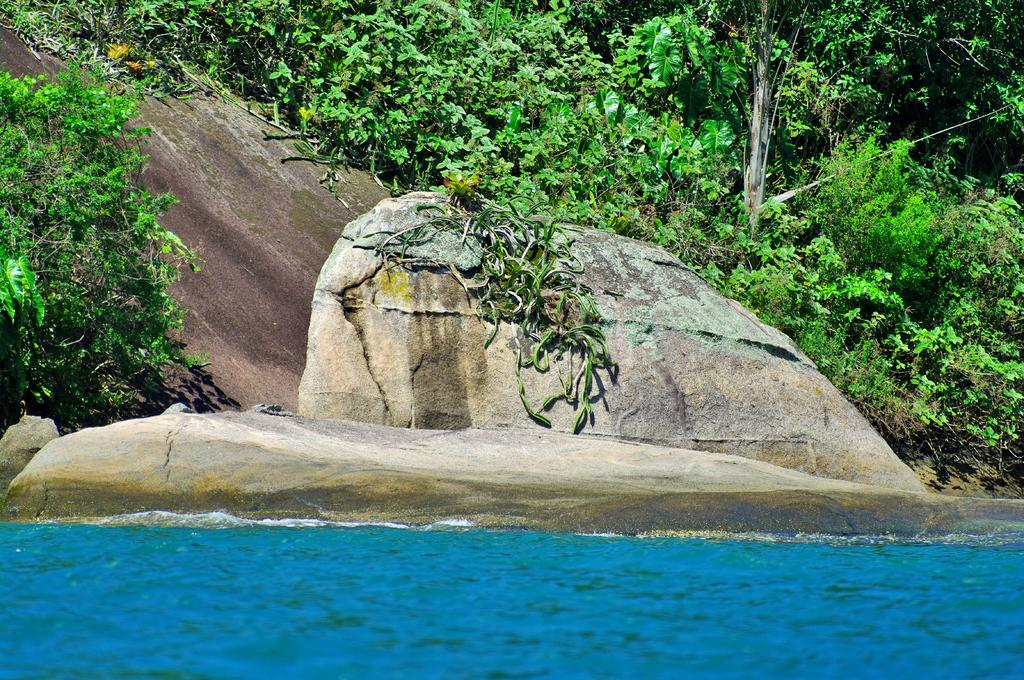What type of body of water is visible in the image? There is a lake in the image. What other natural features can be seen in the image? There are huge rocks in the image. Are there any plants present in the image? Yes, the rocks have plants on either side. What type of music can be heard coming from the rocks in the image? There is no music present in the image; it is a visual representation of a lake and rocks with plants. 